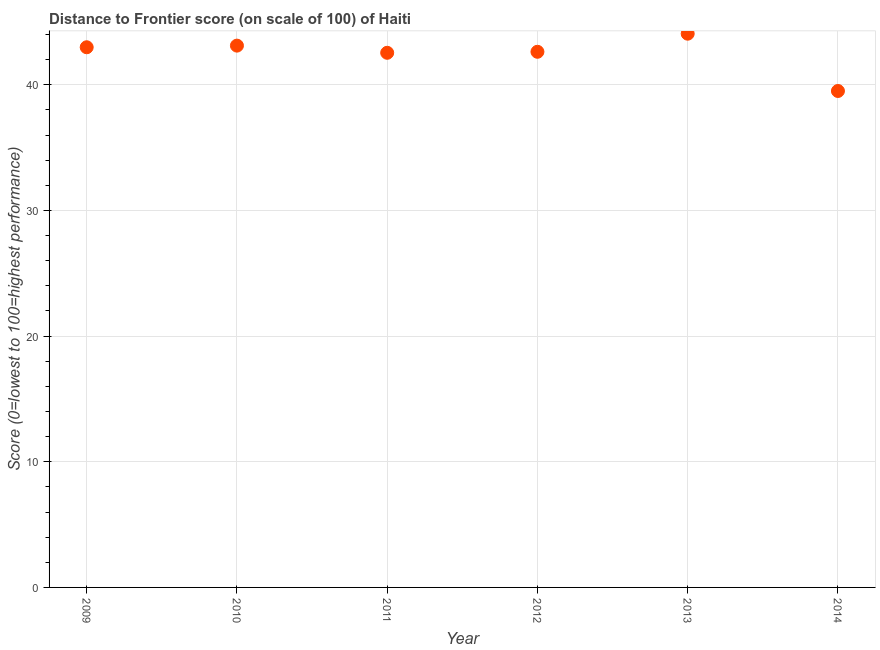What is the distance to frontier score in 2011?
Make the answer very short. 42.55. Across all years, what is the maximum distance to frontier score?
Offer a terse response. 44.07. Across all years, what is the minimum distance to frontier score?
Provide a short and direct response. 39.51. What is the sum of the distance to frontier score?
Give a very brief answer. 254.87. What is the difference between the distance to frontier score in 2012 and 2014?
Your answer should be compact. 3.12. What is the average distance to frontier score per year?
Your answer should be very brief. 42.48. What is the median distance to frontier score?
Ensure brevity in your answer.  42.81. Do a majority of the years between 2009 and 2011 (inclusive) have distance to frontier score greater than 4 ?
Keep it short and to the point. Yes. What is the ratio of the distance to frontier score in 2010 to that in 2014?
Offer a terse response. 1.09. Is the distance to frontier score in 2011 less than that in 2014?
Your answer should be very brief. No. What is the difference between the highest and the second highest distance to frontier score?
Make the answer very short. 0.95. Is the sum of the distance to frontier score in 2010 and 2012 greater than the maximum distance to frontier score across all years?
Make the answer very short. Yes. What is the difference between the highest and the lowest distance to frontier score?
Your response must be concise. 4.56. How many dotlines are there?
Your response must be concise. 1. How many years are there in the graph?
Offer a very short reply. 6. What is the difference between two consecutive major ticks on the Y-axis?
Your response must be concise. 10. Are the values on the major ticks of Y-axis written in scientific E-notation?
Offer a very short reply. No. Does the graph contain any zero values?
Your answer should be compact. No. What is the title of the graph?
Offer a terse response. Distance to Frontier score (on scale of 100) of Haiti. What is the label or title of the Y-axis?
Provide a succinct answer. Score (0=lowest to 100=highest performance). What is the Score (0=lowest to 100=highest performance) in 2009?
Give a very brief answer. 42.99. What is the Score (0=lowest to 100=highest performance) in 2010?
Ensure brevity in your answer.  43.12. What is the Score (0=lowest to 100=highest performance) in 2011?
Make the answer very short. 42.55. What is the Score (0=lowest to 100=highest performance) in 2012?
Offer a terse response. 42.63. What is the Score (0=lowest to 100=highest performance) in 2013?
Your answer should be compact. 44.07. What is the Score (0=lowest to 100=highest performance) in 2014?
Offer a very short reply. 39.51. What is the difference between the Score (0=lowest to 100=highest performance) in 2009 and 2010?
Provide a succinct answer. -0.13. What is the difference between the Score (0=lowest to 100=highest performance) in 2009 and 2011?
Your response must be concise. 0.44. What is the difference between the Score (0=lowest to 100=highest performance) in 2009 and 2012?
Offer a terse response. 0.36. What is the difference between the Score (0=lowest to 100=highest performance) in 2009 and 2013?
Your answer should be compact. -1.08. What is the difference between the Score (0=lowest to 100=highest performance) in 2009 and 2014?
Make the answer very short. 3.48. What is the difference between the Score (0=lowest to 100=highest performance) in 2010 and 2011?
Provide a short and direct response. 0.57. What is the difference between the Score (0=lowest to 100=highest performance) in 2010 and 2012?
Ensure brevity in your answer.  0.49. What is the difference between the Score (0=lowest to 100=highest performance) in 2010 and 2013?
Your answer should be compact. -0.95. What is the difference between the Score (0=lowest to 100=highest performance) in 2010 and 2014?
Ensure brevity in your answer.  3.61. What is the difference between the Score (0=lowest to 100=highest performance) in 2011 and 2012?
Provide a short and direct response. -0.08. What is the difference between the Score (0=lowest to 100=highest performance) in 2011 and 2013?
Provide a succinct answer. -1.52. What is the difference between the Score (0=lowest to 100=highest performance) in 2011 and 2014?
Offer a terse response. 3.04. What is the difference between the Score (0=lowest to 100=highest performance) in 2012 and 2013?
Your answer should be compact. -1.44. What is the difference between the Score (0=lowest to 100=highest performance) in 2012 and 2014?
Your answer should be compact. 3.12. What is the difference between the Score (0=lowest to 100=highest performance) in 2013 and 2014?
Make the answer very short. 4.56. What is the ratio of the Score (0=lowest to 100=highest performance) in 2009 to that in 2012?
Keep it short and to the point. 1.01. What is the ratio of the Score (0=lowest to 100=highest performance) in 2009 to that in 2013?
Your answer should be very brief. 0.97. What is the ratio of the Score (0=lowest to 100=highest performance) in 2009 to that in 2014?
Give a very brief answer. 1.09. What is the ratio of the Score (0=lowest to 100=highest performance) in 2010 to that in 2012?
Give a very brief answer. 1.01. What is the ratio of the Score (0=lowest to 100=highest performance) in 2010 to that in 2014?
Provide a succinct answer. 1.09. What is the ratio of the Score (0=lowest to 100=highest performance) in 2011 to that in 2012?
Ensure brevity in your answer.  1. What is the ratio of the Score (0=lowest to 100=highest performance) in 2011 to that in 2013?
Provide a short and direct response. 0.97. What is the ratio of the Score (0=lowest to 100=highest performance) in 2011 to that in 2014?
Ensure brevity in your answer.  1.08. What is the ratio of the Score (0=lowest to 100=highest performance) in 2012 to that in 2013?
Ensure brevity in your answer.  0.97. What is the ratio of the Score (0=lowest to 100=highest performance) in 2012 to that in 2014?
Provide a succinct answer. 1.08. What is the ratio of the Score (0=lowest to 100=highest performance) in 2013 to that in 2014?
Give a very brief answer. 1.11. 